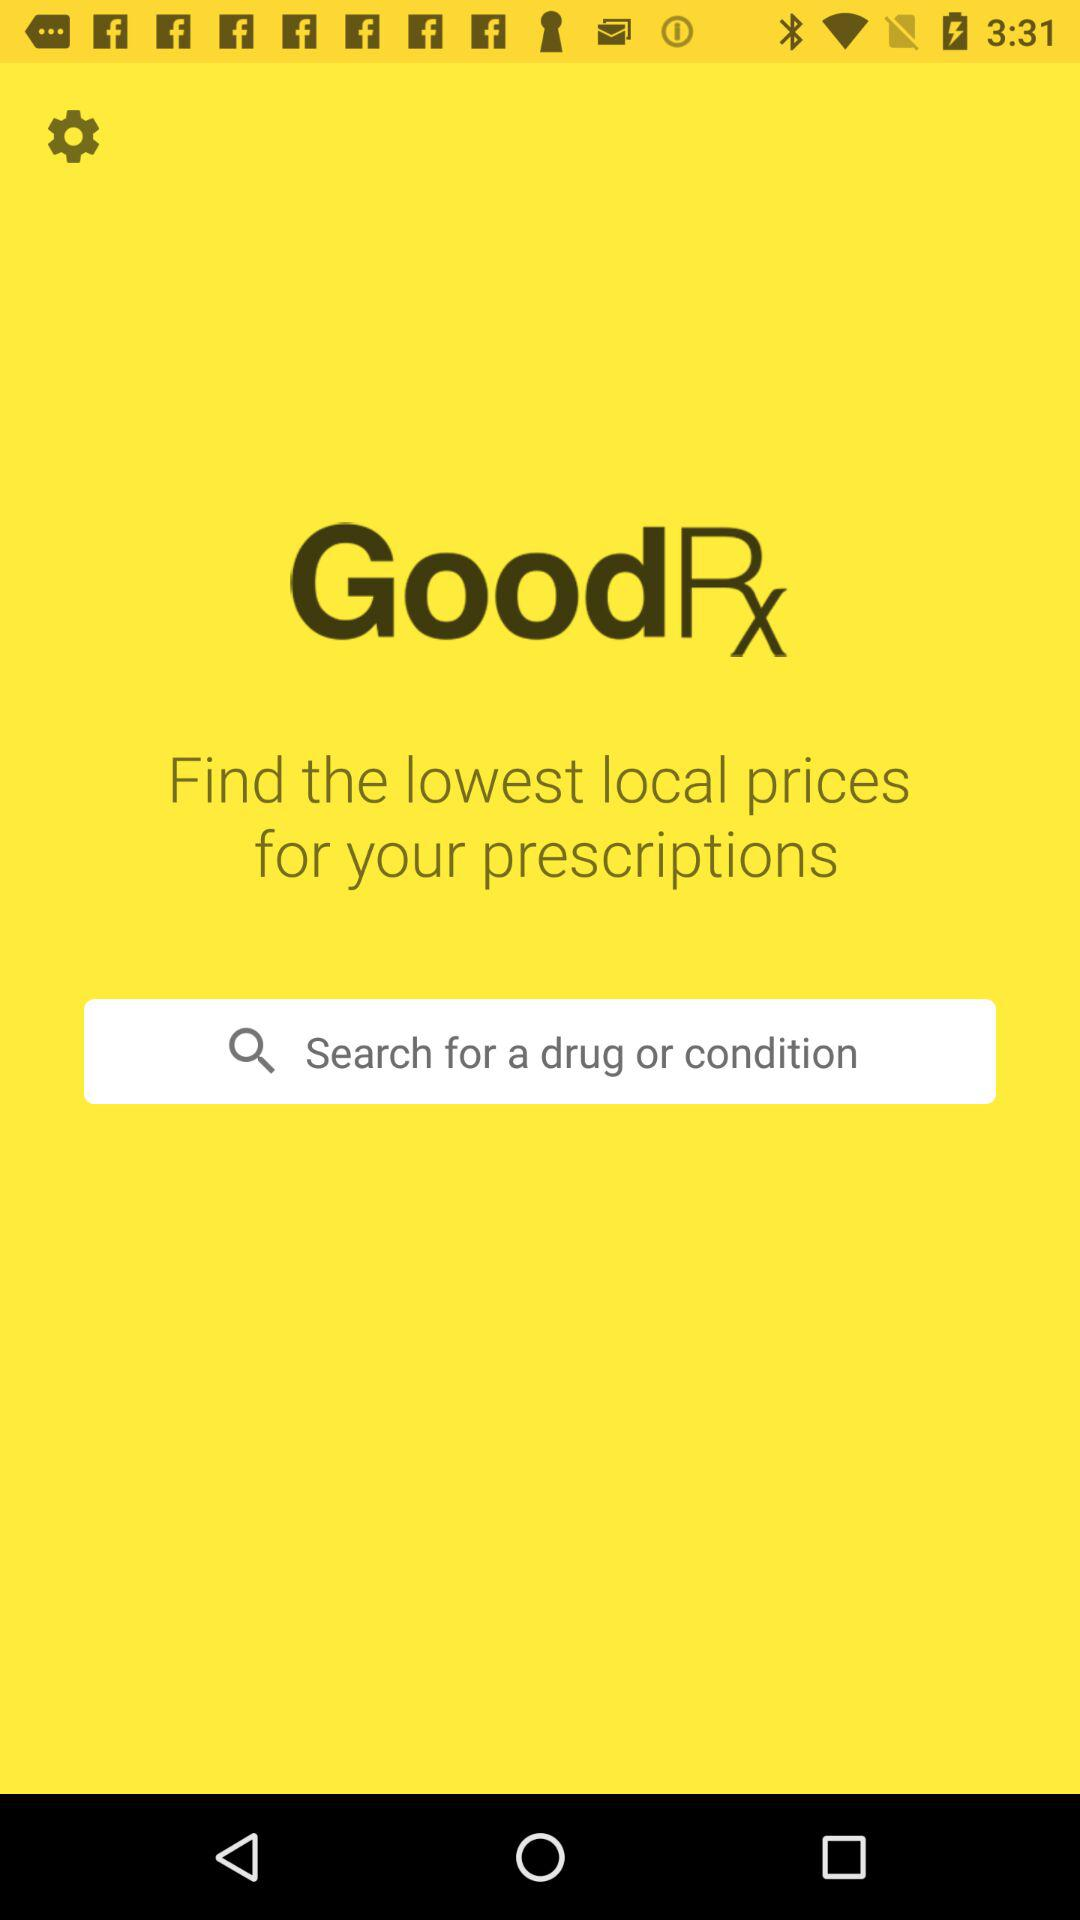How often are the lowest local prices updated?
When the provided information is insufficient, respond with <no answer>. <no answer> 